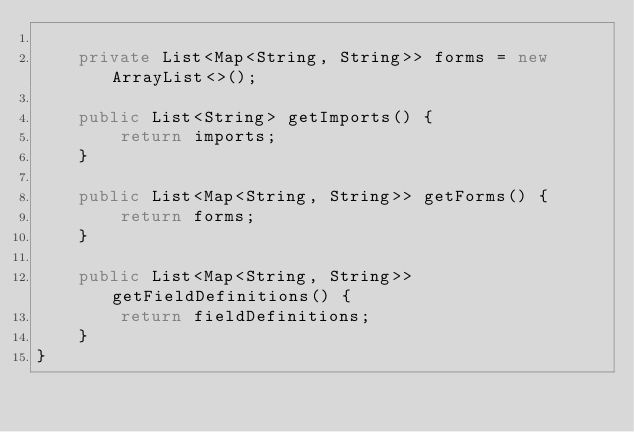<code> <loc_0><loc_0><loc_500><loc_500><_Java_>
    private List<Map<String, String>> forms = new ArrayList<>();

    public List<String> getImports() {
        return imports;
    }

    public List<Map<String, String>> getForms() {
        return forms;
    }

    public List<Map<String, String>> getFieldDefinitions() {
        return fieldDefinitions;
    }
}
</code> 